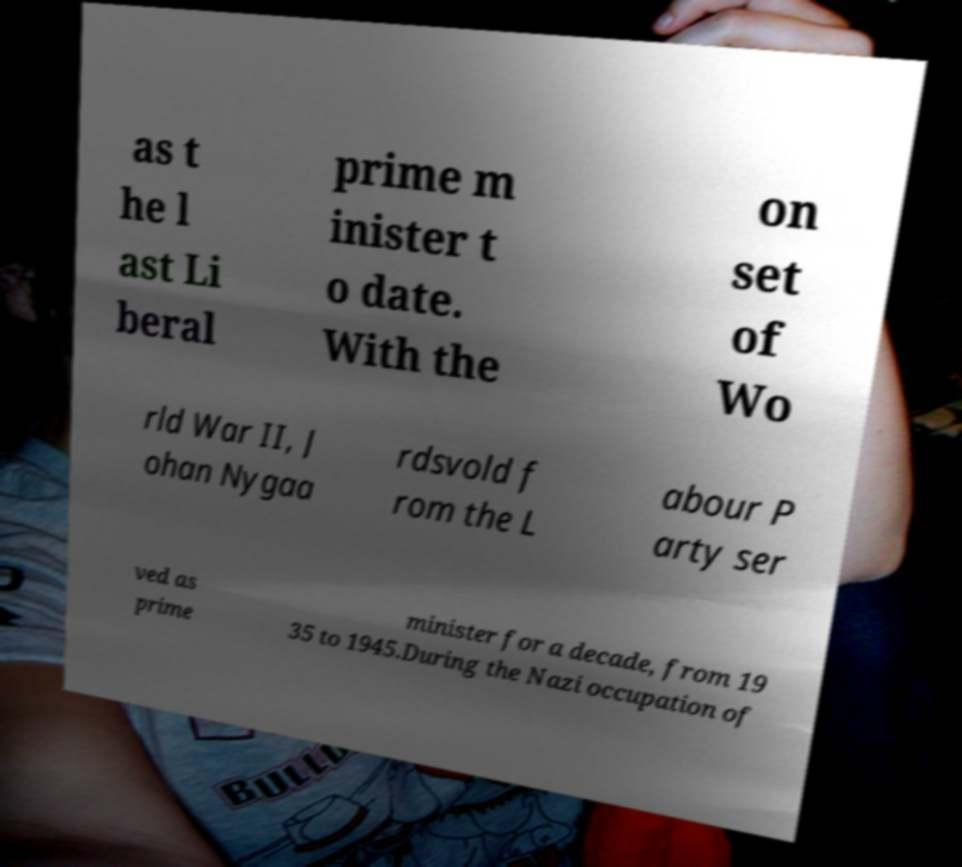For documentation purposes, I need the text within this image transcribed. Could you provide that? as t he l ast Li beral prime m inister t o date. With the on set of Wo rld War II, J ohan Nygaa rdsvold f rom the L abour P arty ser ved as prime minister for a decade, from 19 35 to 1945.During the Nazi occupation of 